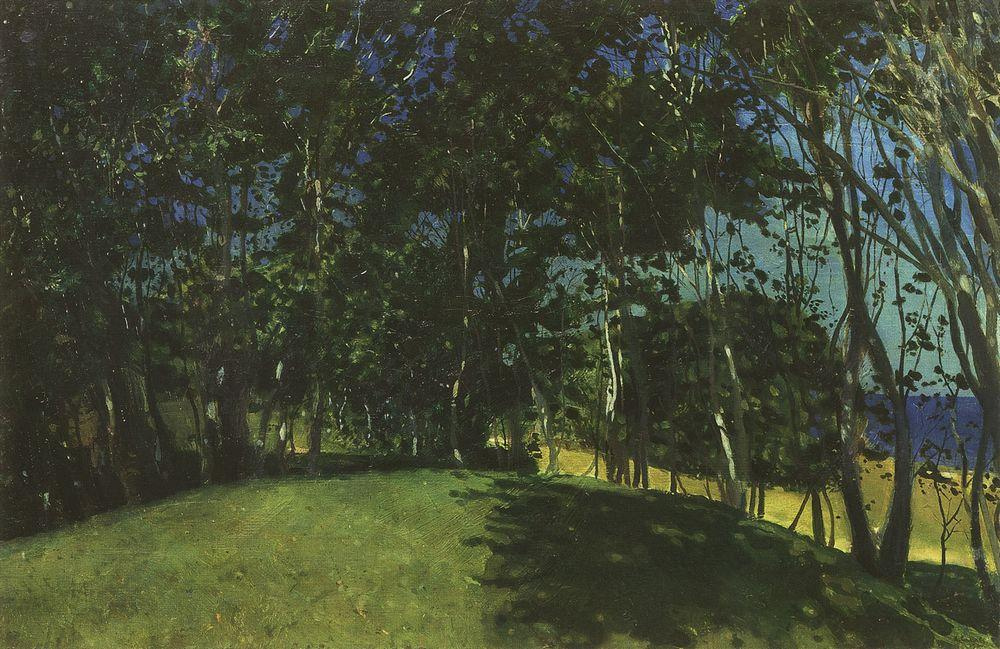How might the choice of colors affect our interpretation of this scene? The artist's choice of colors is quite deliberate, with the predominance of greens conveying a sense of growth, renewal, and the lushness of nature. The contrasting blues suggest tranquility and depth, perhaps hinting at the presence of water or the vastness of the sky. These colors can evoke a range of emotional responses from the viewer, imbuing the scene with a calming and meditative quality. Furthermore, the use of shadow and light creates a vibrant energy, suggesting the lively interplay between the sun's rays and the natural elements within the painting. 